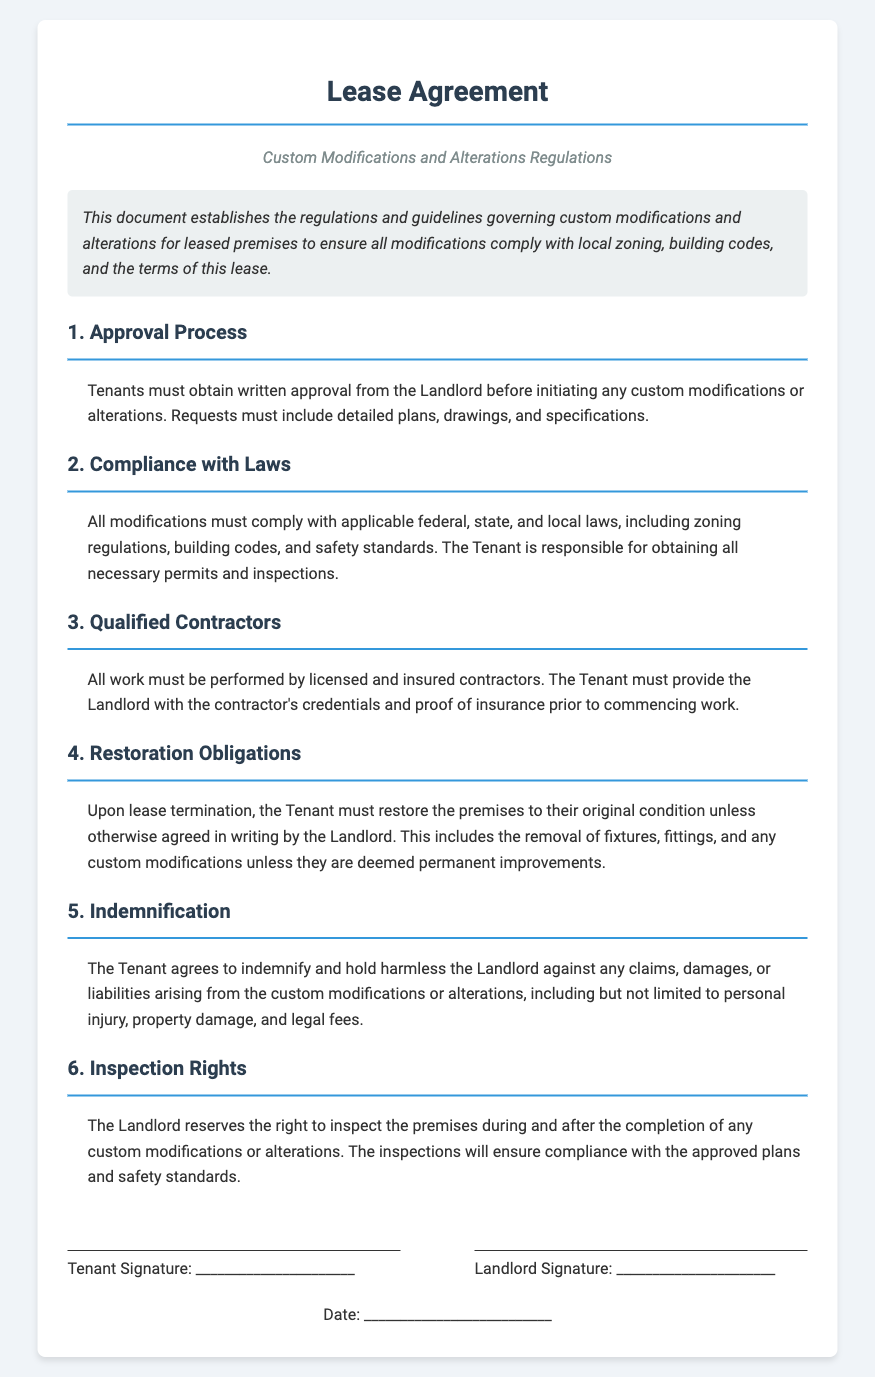What must tenants obtain before starting custom modifications? According to the document, tenants must obtain written approval from the Landlord before initiating any custom modifications or alterations.
Answer: written approval Who is responsible for ensuring modifications comply with laws? The document states that the Tenant is responsible for obtaining all necessary permits and inspections to ensure compliance with applicable laws.
Answer: Tenant What type of contractors must be used for modifications? The document specifies that all work must be performed by licensed and insured contractors.
Answer: licensed and insured contractors What must the tenant do upon lease termination? The document indicates that the Tenant must restore the premises to their original condition unless otherwise agreed in writing by the Landlord.
Answer: restore the premises What does the Tenant agree to in terms of liabilities? The Tenant agrees to indemnify and hold harmless the Landlord against any claims, damages, or liabilities arising from the modifications.
Answer: indemnify and hold harmless What right does the Landlord have concerning inspections? The document states that the Landlord reserves the right to inspect the premises during and after the completion of any modifications.
Answer: inspect the premises What is required in the modification request? Tenants must include detailed plans, drawings, and specifications in their modification request.
Answer: detailed plans, drawings, and specifications What is to be removed by the Tenant during restoration? The Tenant is required to remove fixtures, fittings, and any custom modifications unless they are deemed permanent improvements.
Answer: fixtures, fittings, and custom modifications 